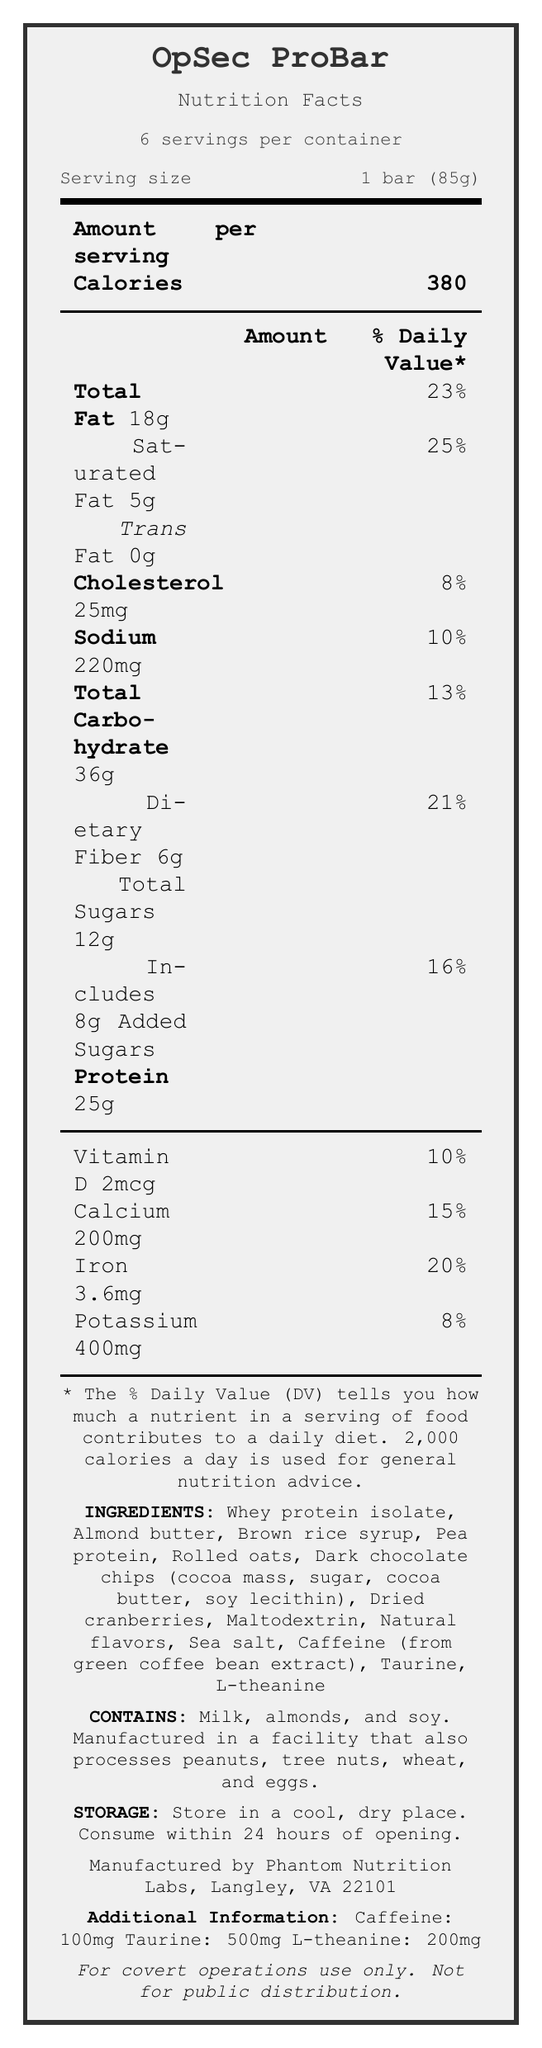what is the serving size? The serving size section states "Serving size 1 bar (85g)" clearly.
Answer: 1 bar (85g) how many servings per container are there? The document specifies "6 servings per container."
Answer: 6 how much total fat is in one serving? The total fat amount is explicitly mentioned as "Total Fat 18g."
Answer: 18g what percentage of the daily value of iron is one serving? The table with vitamins shows "Iron 3.6mg" and its % daily value as "20%."
Answer: 20% how much protein is in one serving of the OpSec ProBar? The amount of protein per serving is shown as "Protein 25g."
Answer: 25g which type of fat is not present in the OpSec ProBar? A. Trans fat B. Saturated fat C. Total fat D. Cholesterol The label states "Trans Fat 0g," indicating it is not present.
Answer: A how much caffeine is in one serving of the OpSec ProBar? A. 50mg B. 75mg C. 100mg D. 25mg The additional information section lists "Caffeine: 100mg."
Answer: C is this product suitable for someone with a peanut allergy? The allergen information states "Manufactured in a facility that also processes peanuts," posing a risk for those with peanut allergies.
Answer: No does the OpSec ProBar contain added sugars? The document lists "Includes 8g Added Sugars" under the total carbohydrate section.
Answer: Yes summarize the main idea of the OpSec ProBar Nutrition Facts document. The document provides detailed nutritional information, ingredients, allergen warnings, storage instructions, and unique features of the OpSec ProBar.
Answer: The OpSec ProBar is a high-energy protein bar specifically designed for covert operatives, offering sustained energy and enhanced focus. It contains 380 calories per serving, with notable amounts of protein, fat, and carbohydrates, as well as added nootropics like caffeine, taurine, and L-theanine. It's packaged to be practical for covert operations. how much fiber is in one serving of the OpSec ProBar? The dietary fiber content is listed as "Dietary Fiber 6g" under the total carbohydrate section.
Answer: 6g what is the percentage of daily value for saturated fat in one serving? The amount and daily value of saturated fat are shown as 5g and 25% respectively.
Answer: 25% where is the OpSec ProBar manufactured? The manufacturer information section specifies "Manufactured by Phantom Nutrition Labs, Langley, VA 22101."
Answer: Langley, VA 22101 how many grams of total sugars are in one serving? The total sugars content per serving is listed as "Total Sugars 12g."
Answer: 12g name one ingredient of the OpSec ProBar that is also commonly used as a sports supplement for mental alertness. The document lists "Caffeine (from green coffee bean extract)" as one of the ingredients, known for its mental alertness benefits.
Answer: Caffeine what is the main purpose of the matte black wrapper for the OpSec ProBar? The covert features list "Matte black wrapper to minimize reflection during nighttime operations."
Answer: To minimize reflection during nighttime operations how many vitamins or minerals are listed with their daily values? The vitamins and minerals with daily values listed are Vitamin D, Calcium, Iron, and Potassium.
Answer: 4 can I consume this product if I have a soy allergy? The allergen information states "Contains milk, almonds, and soy," clearly indicating it contains soy.
Answer: No what benefits do the added nootropics contribute to the OpSec ProBar? The covert features section mentions "Enhanced with nootropics for improved focus and alertness."
Answer: Improved focus and alertness how does the packaging of the OpSec ProBar support covert operations? The covert features highlight practical attributes like vacuum-sealed packaging, matte black wrapper, and tear-resistant packaging designed for covert operations.
Answer: Vacuum-sealed and matte black for extended shelf life and minimal reflection, along with tear-resistant packaging for silent opening 